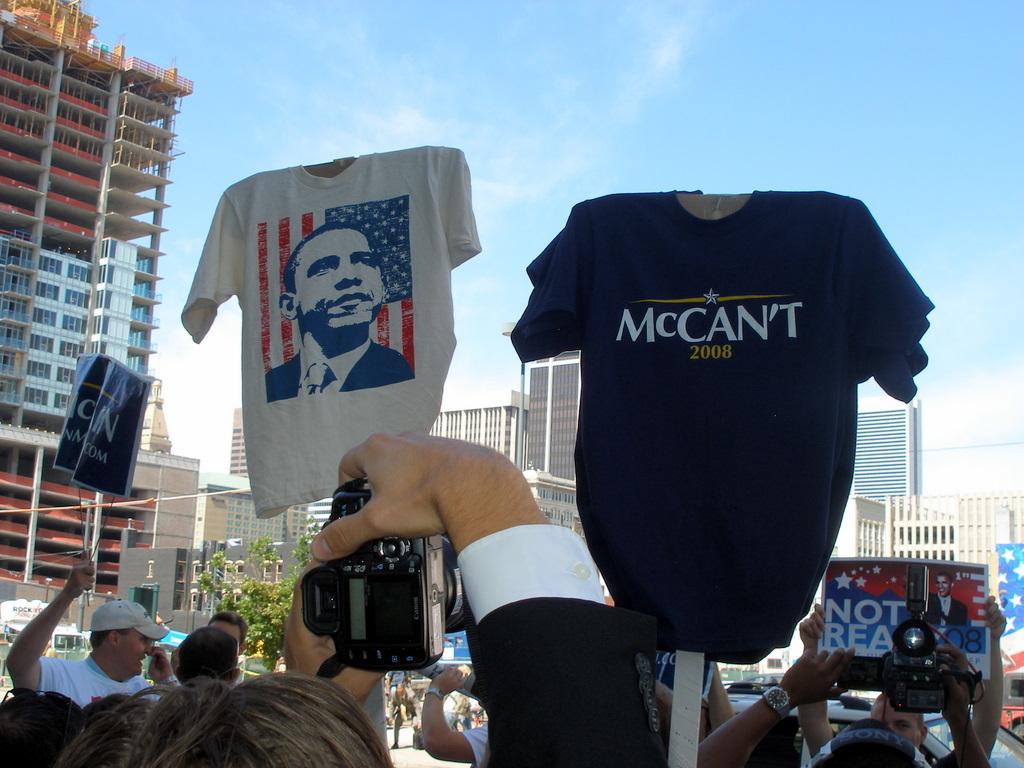What presidential election is on the dark colored shirt?
Your answer should be very brief. 2008. What year is on the shirt on the right?
Provide a short and direct response. 2008. 